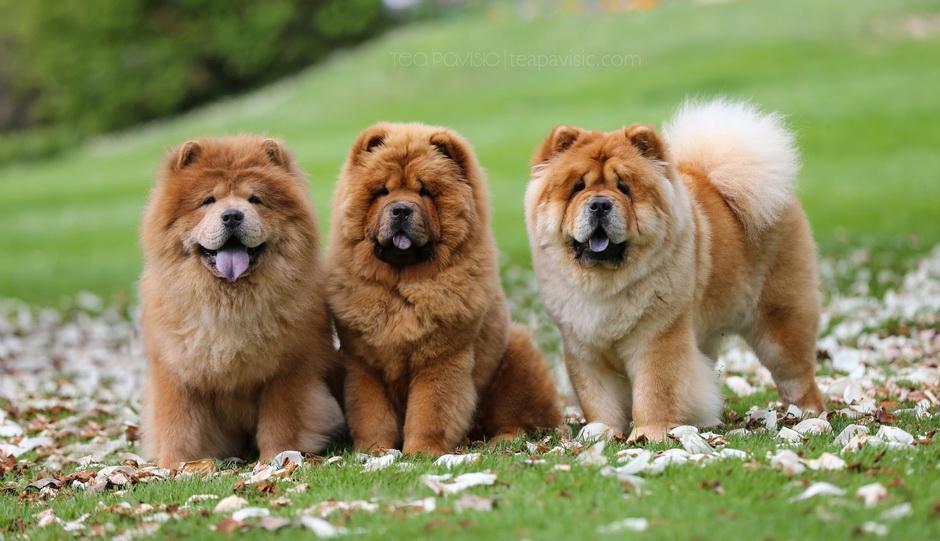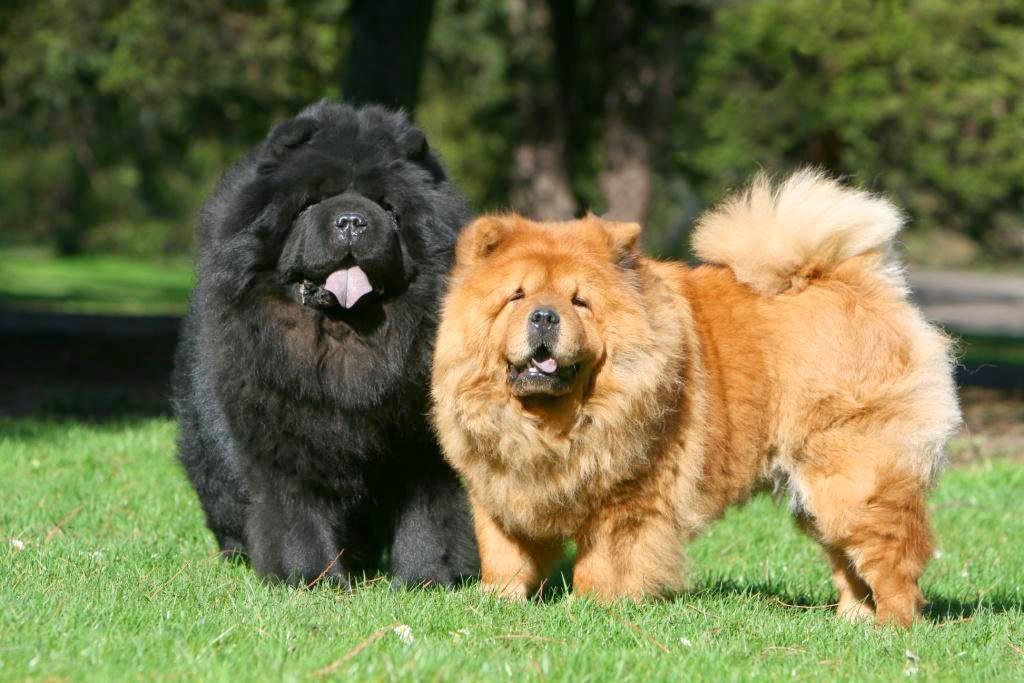The first image is the image on the left, the second image is the image on the right. Considering the images on both sides, is "In one of the image the dog is laying on a bed." valid? Answer yes or no. No. The first image is the image on the left, the second image is the image on the right. Considering the images on both sides, is "All Chow dogs are on the grass." valid? Answer yes or no. Yes. 